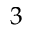Convert formula to latex. <formula><loc_0><loc_0><loc_500><loc_500>3</formula> 